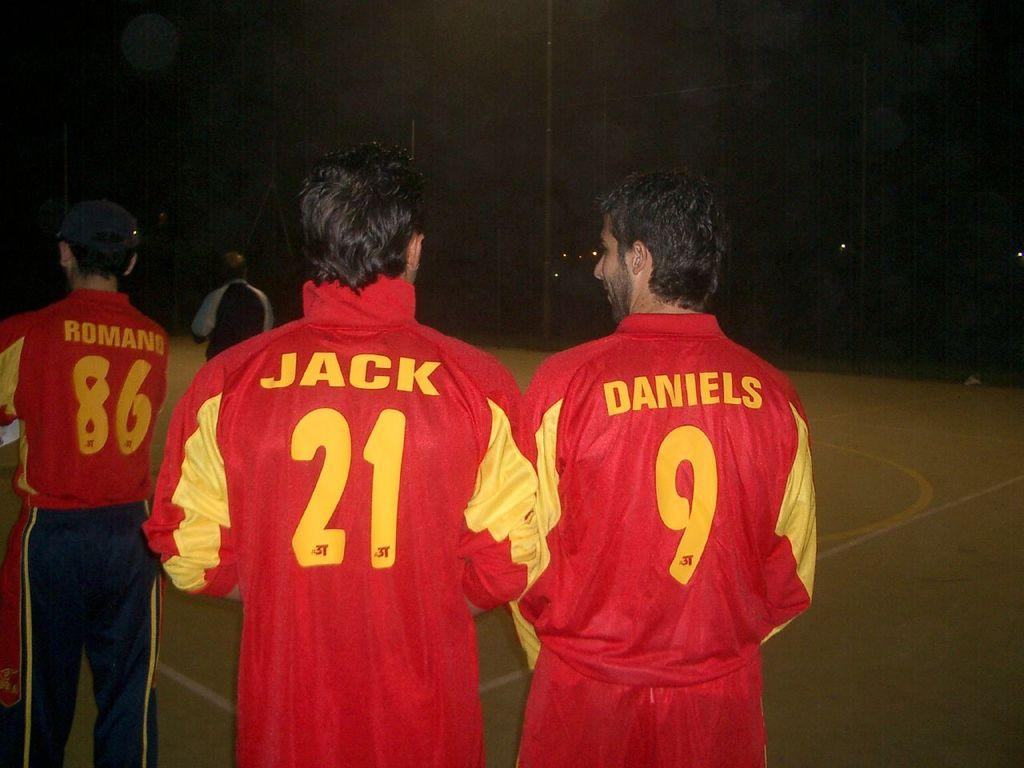Provide a one-sentence caption for the provided image. Two men are wearing matching red sport jackets that sayd "jack" on one and "daniels" on the other. 